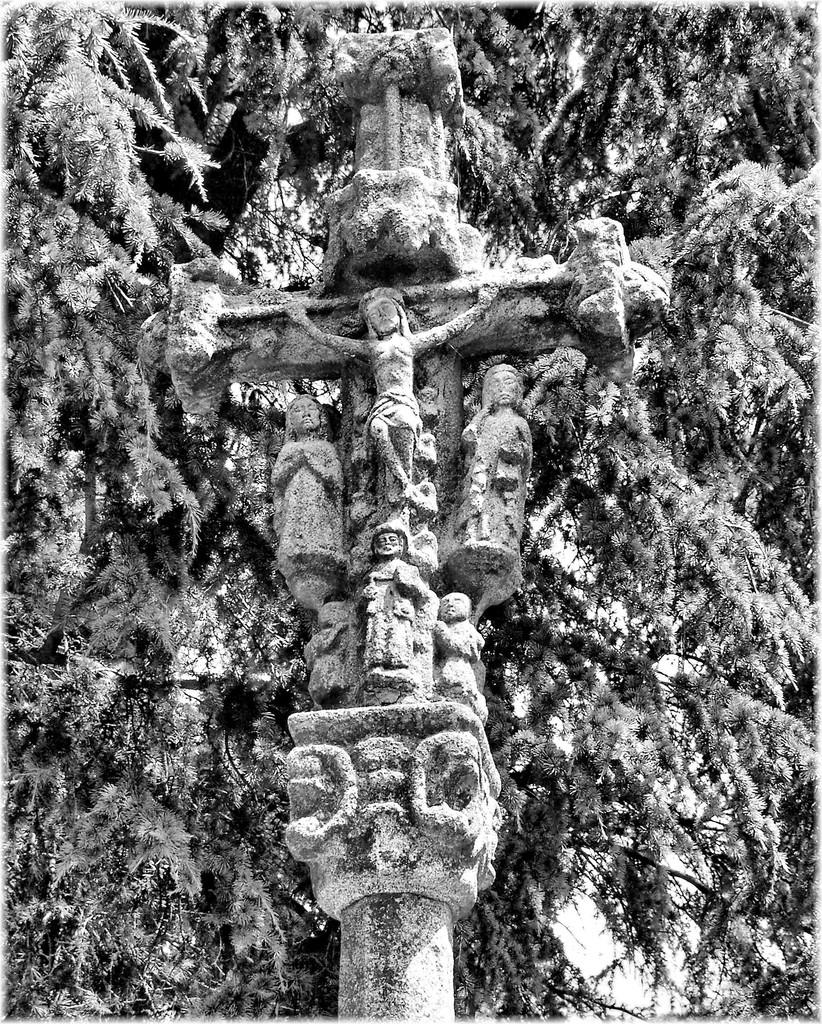What is the color scheme of the image? The image is black and white. What can be seen in the image besides the color scheme? There are sculptures in the image. Where are the sculptures located? The sculptures are on a cross symbol. What can be seen in the background of the image? There are trees in the background of the image. How many fish are swimming around the cross symbol in the image? There are no fish present in the image; it features sculptures on a cross symbol. What type of connection can be seen between the sculptures in the image? There is no specific connection between the sculptures mentioned in the image; they are simply located on a cross symbol. 